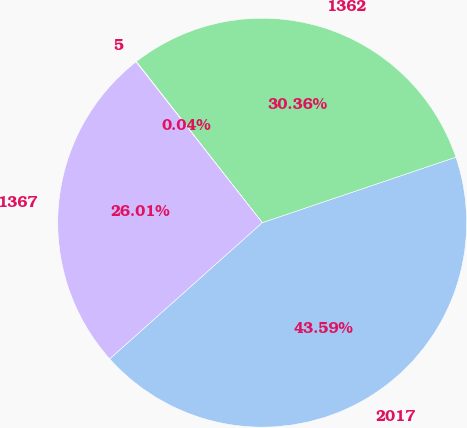<chart> <loc_0><loc_0><loc_500><loc_500><pie_chart><fcel>2017<fcel>1362<fcel>5<fcel>1367<nl><fcel>43.59%<fcel>30.36%<fcel>0.04%<fcel>26.01%<nl></chart> 